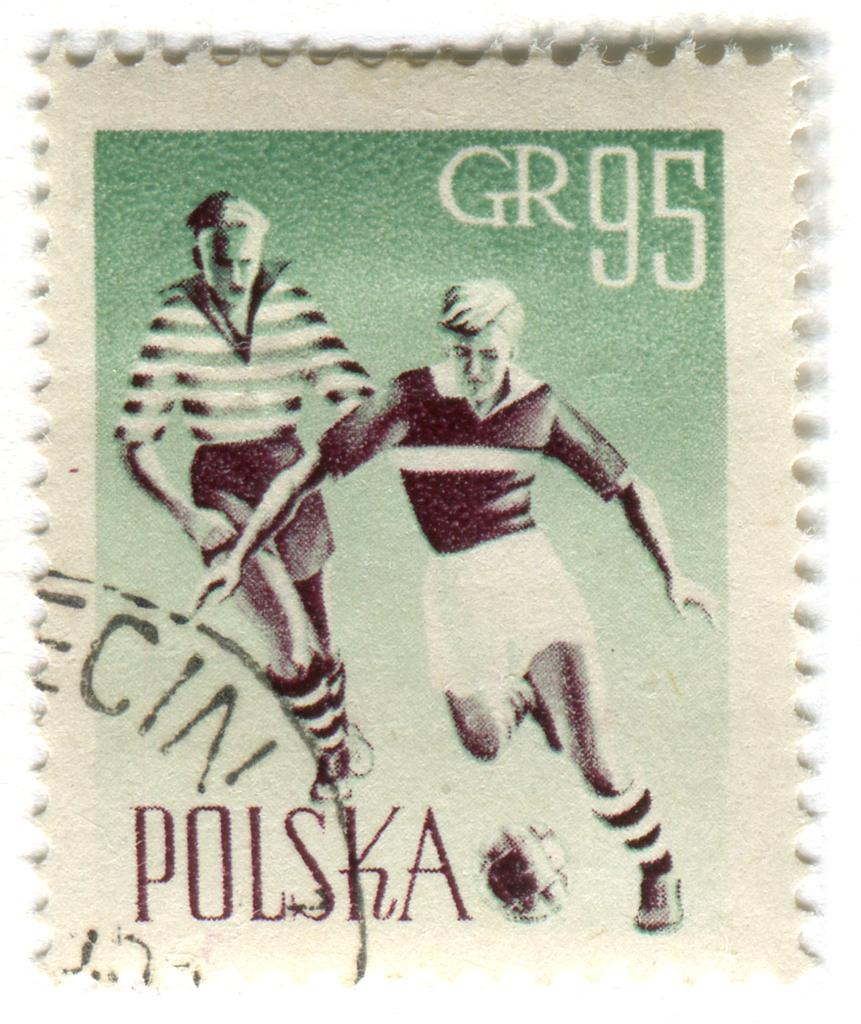What is present in the image that contains information or visuals? There is a paper in the image. What can be seen on the paper? The paper contains images of two people. Is there any text on the paper? Yes, there is text on the paper. How many snails can be seen on the paper in the image? There are no snails present on the paper in the image. What type of power is being generated by the people in the images on the paper? The images on the paper do not depict any power generation; they simply show two people. 